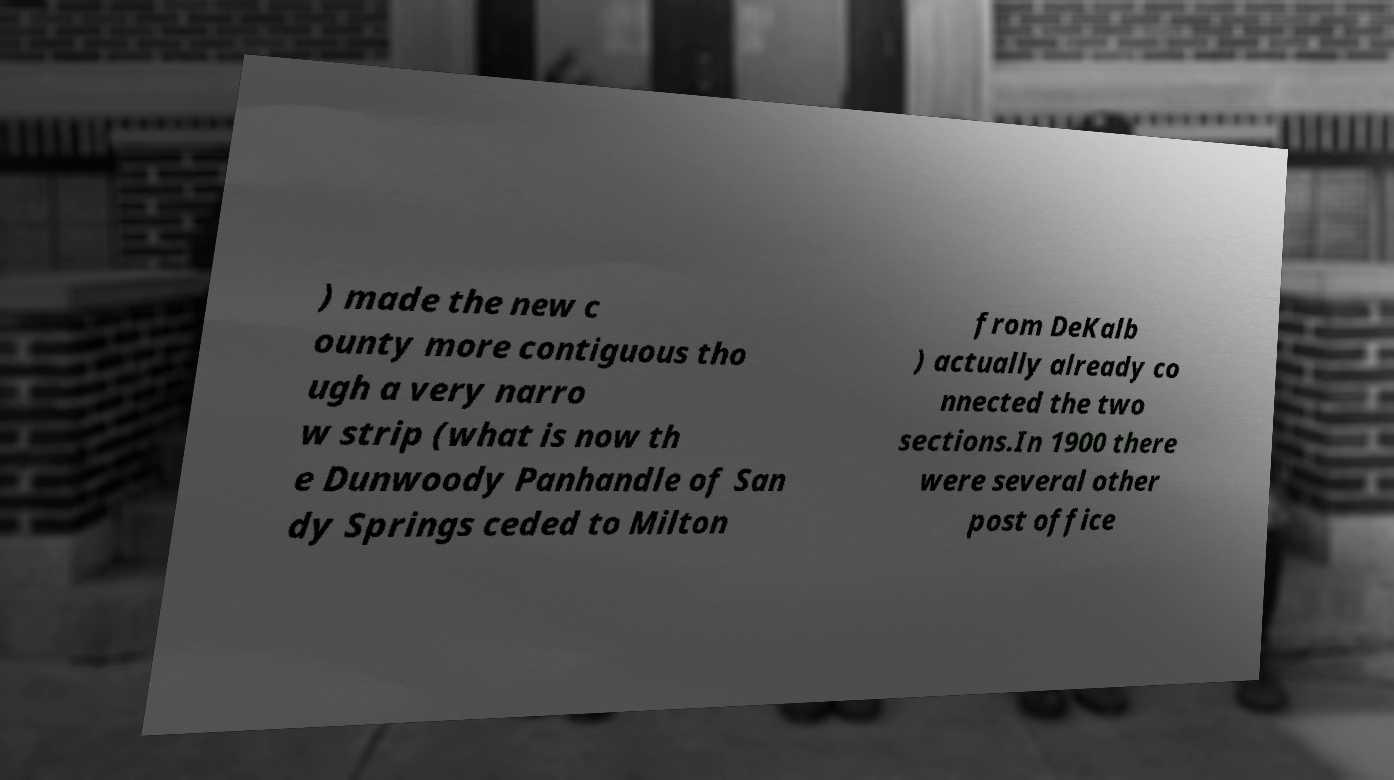Can you read and provide the text displayed in the image?This photo seems to have some interesting text. Can you extract and type it out for me? ) made the new c ounty more contiguous tho ugh a very narro w strip (what is now th e Dunwoody Panhandle of San dy Springs ceded to Milton from DeKalb ) actually already co nnected the two sections.In 1900 there were several other post office 